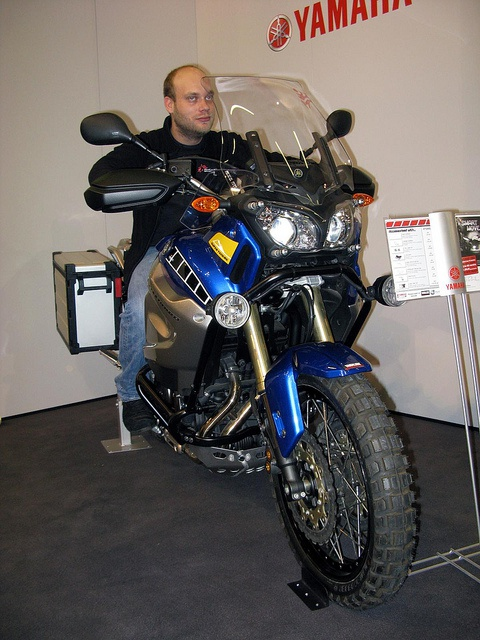Describe the objects in this image and their specific colors. I can see motorcycle in gray, black, darkgray, and navy tones, people in gray, black, and blue tones, and people in gray, black, and tan tones in this image. 